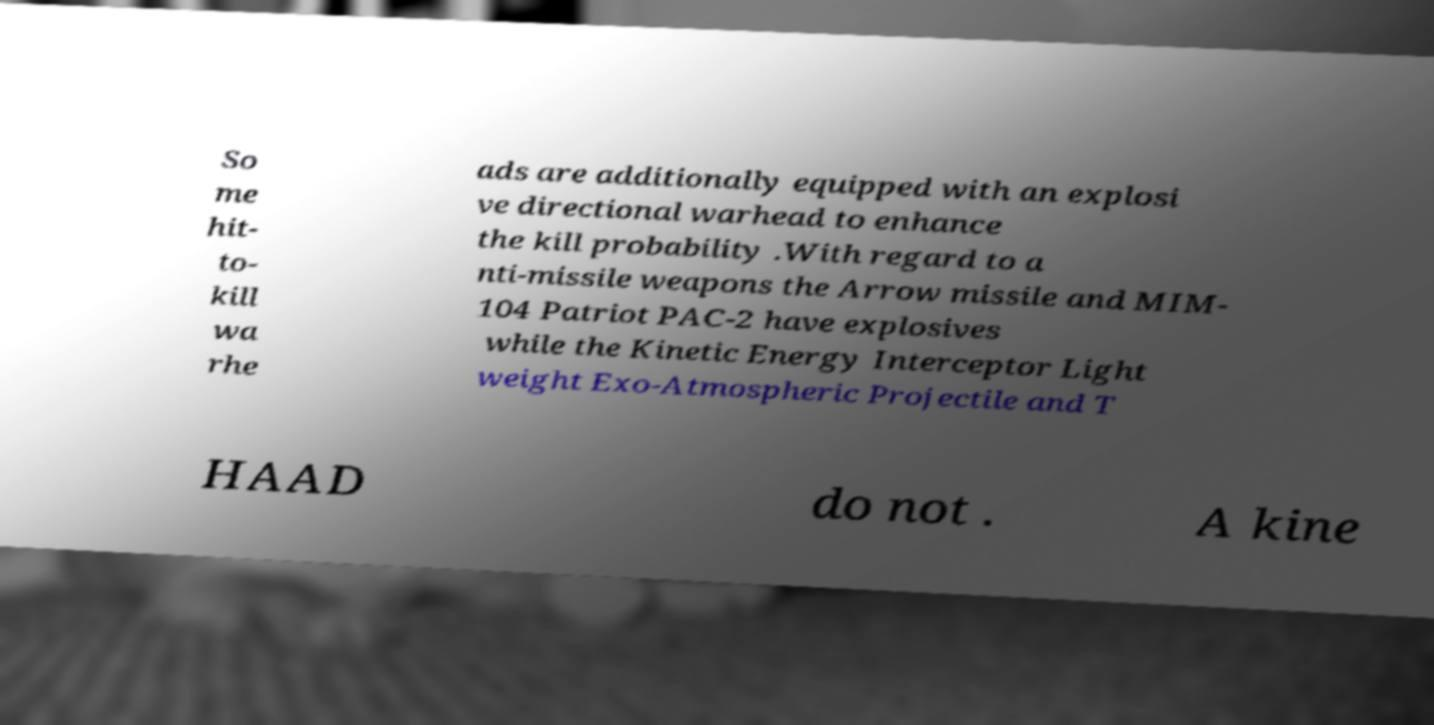Please identify and transcribe the text found in this image. So me hit- to- kill wa rhe ads are additionally equipped with an explosi ve directional warhead to enhance the kill probability .With regard to a nti-missile weapons the Arrow missile and MIM- 104 Patriot PAC-2 have explosives while the Kinetic Energy Interceptor Light weight Exo-Atmospheric Projectile and T HAAD do not . A kine 